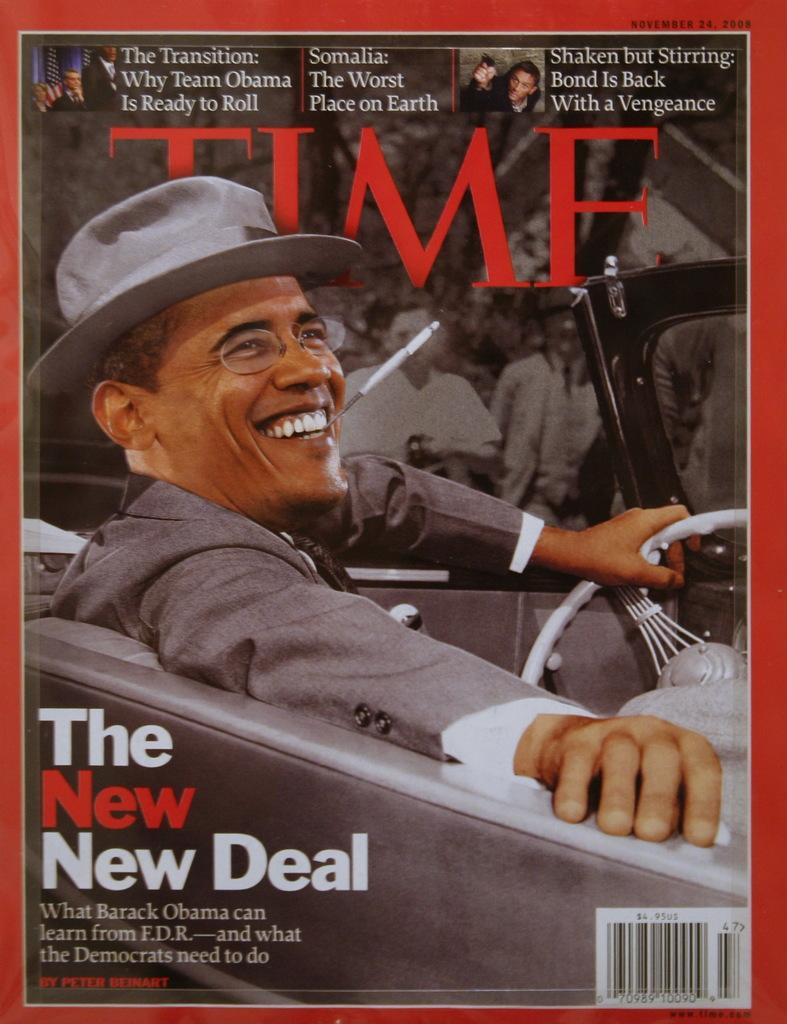<image>
Render a clear and concise summary of the photo. A TIME magazine cover showing Barack Obama and featuring the story "The New New Deal". 